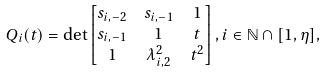<formula> <loc_0><loc_0><loc_500><loc_500>& Q _ { i } ( t ) = \det \begin{bmatrix} s _ { i , - 2 } & s _ { i , - 1 } & 1 \\ s _ { i , - 1 } & 1 & t \\ 1 & \lambda _ { i , 2 } ^ { 2 } & t ^ { 2 } \end{bmatrix} , i \in \mathbb { N } \cap [ 1 , \eta ] ,</formula> 